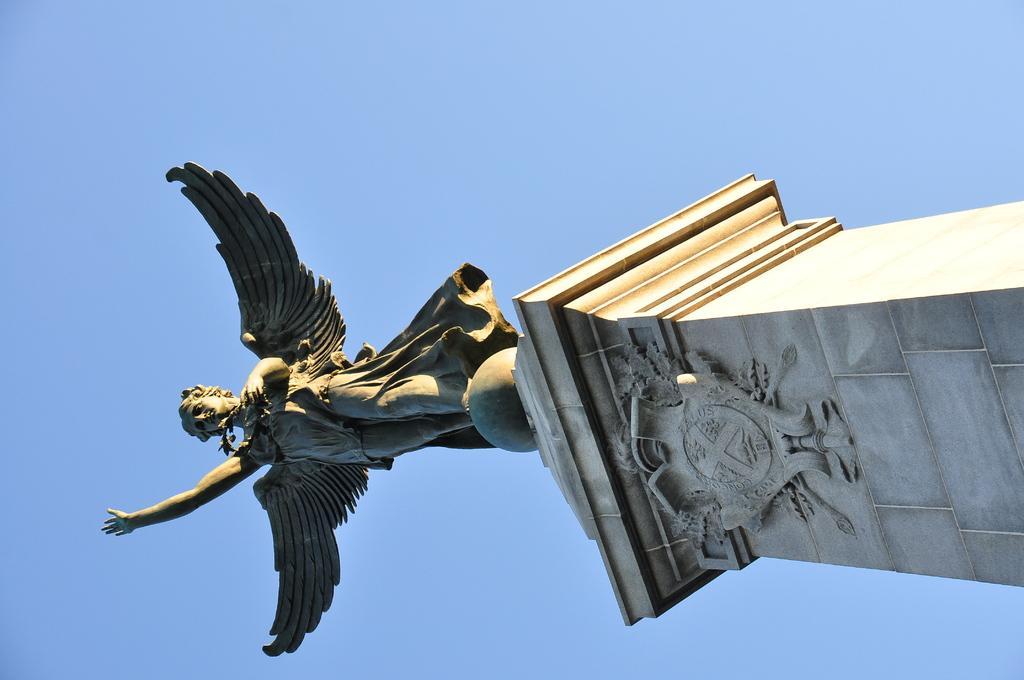Could you give a brief overview of what you see in this image? In this image we can see a statue on a pillar. Behind the statue we can see the sky. 